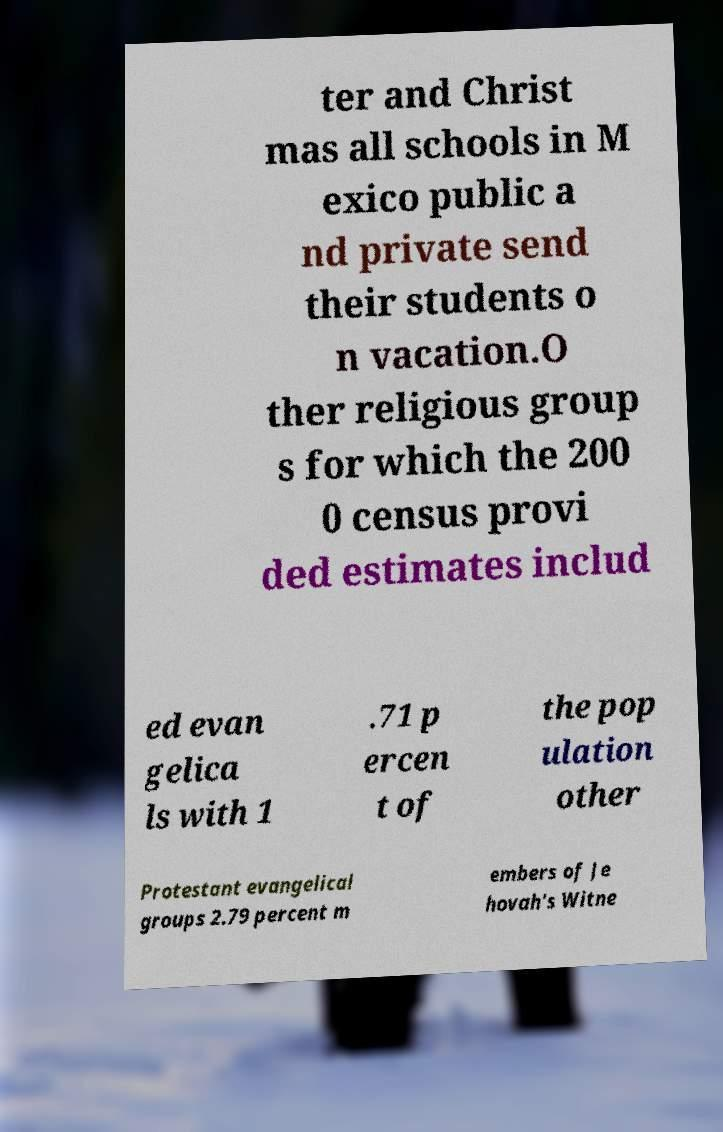Can you accurately transcribe the text from the provided image for me? ter and Christ mas all schools in M exico public a nd private send their students o n vacation.O ther religious group s for which the 200 0 census provi ded estimates includ ed evan gelica ls with 1 .71 p ercen t of the pop ulation other Protestant evangelical groups 2.79 percent m embers of Je hovah's Witne 